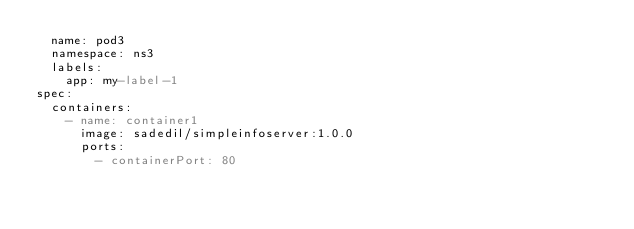Convert code to text. <code><loc_0><loc_0><loc_500><loc_500><_YAML_>  name: pod3
  namespace: ns3
  labels:
    app: my-label-1
spec:
  containers:
    - name: container1
      image: sadedil/simpleinfoserver:1.0.0
      ports:
        - containerPort: 80</code> 